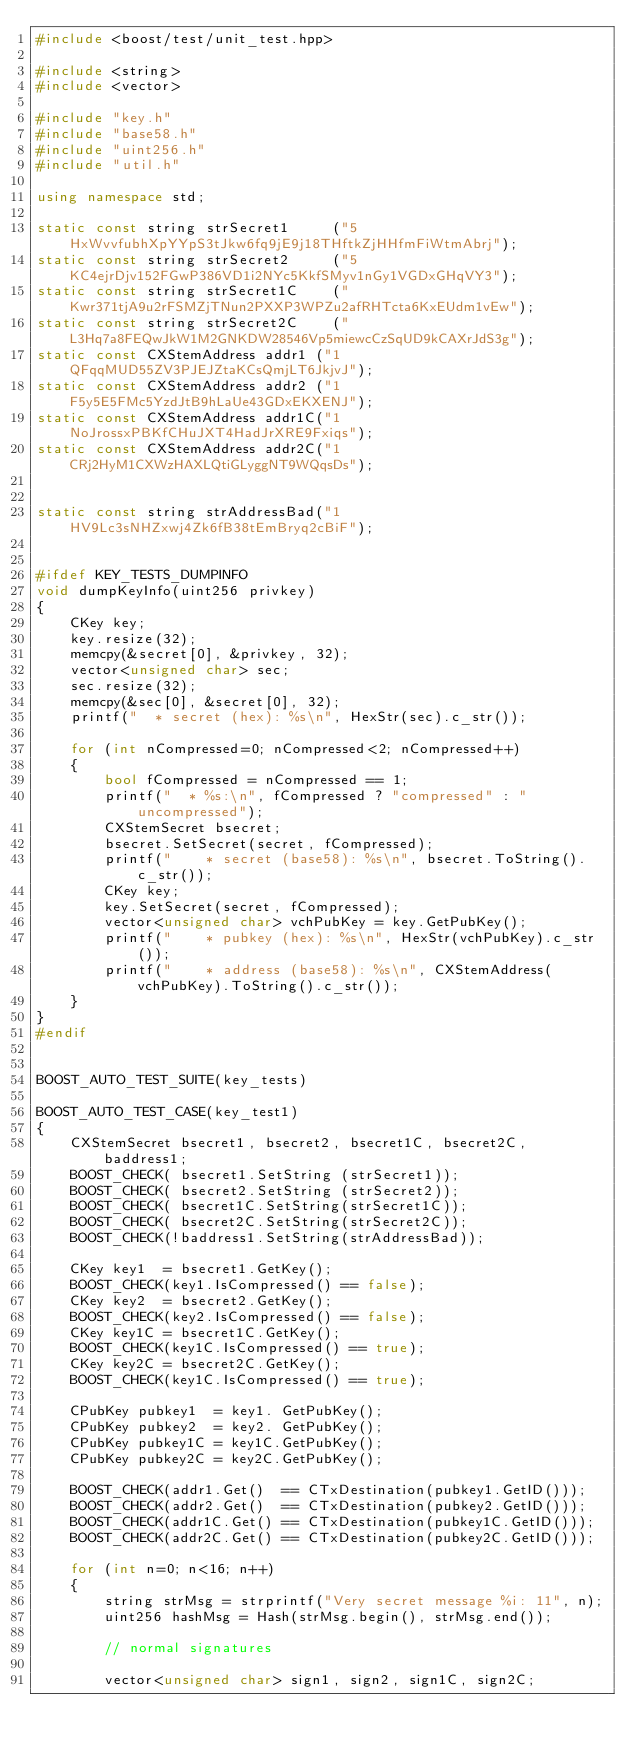Convert code to text. <code><loc_0><loc_0><loc_500><loc_500><_C++_>#include <boost/test/unit_test.hpp>

#include <string>
#include <vector>

#include "key.h"
#include "base58.h"
#include "uint256.h"
#include "util.h"

using namespace std;

static const string strSecret1     ("5HxWvvfubhXpYYpS3tJkw6fq9jE9j18THftkZjHHfmFiWtmAbrj");
static const string strSecret2     ("5KC4ejrDjv152FGwP386VD1i2NYc5KkfSMyv1nGy1VGDxGHqVY3");
static const string strSecret1C    ("Kwr371tjA9u2rFSMZjTNun2PXXP3WPZu2afRHTcta6KxEUdm1vEw");
static const string strSecret2C    ("L3Hq7a8FEQwJkW1M2GNKDW28546Vp5miewcCzSqUD9kCAXrJdS3g");
static const CXStemAddress addr1 ("1QFqqMUD55ZV3PJEJZtaKCsQmjLT6JkjvJ");
static const CXStemAddress addr2 ("1F5y5E5FMc5YzdJtB9hLaUe43GDxEKXENJ");
static const CXStemAddress addr1C("1NoJrossxPBKfCHuJXT4HadJrXRE9Fxiqs");
static const CXStemAddress addr2C("1CRj2HyM1CXWzHAXLQtiGLyggNT9WQqsDs");


static const string strAddressBad("1HV9Lc3sNHZxwj4Zk6fB38tEmBryq2cBiF");


#ifdef KEY_TESTS_DUMPINFO
void dumpKeyInfo(uint256 privkey)
{
    CKey key;
    key.resize(32);
    memcpy(&secret[0], &privkey, 32);
    vector<unsigned char> sec;
    sec.resize(32);
    memcpy(&sec[0], &secret[0], 32);
    printf("  * secret (hex): %s\n", HexStr(sec).c_str());

    for (int nCompressed=0; nCompressed<2; nCompressed++)
    {
        bool fCompressed = nCompressed == 1;
        printf("  * %s:\n", fCompressed ? "compressed" : "uncompressed");
        CXStemSecret bsecret;
        bsecret.SetSecret(secret, fCompressed);
        printf("    * secret (base58): %s\n", bsecret.ToString().c_str());
        CKey key;
        key.SetSecret(secret, fCompressed);
        vector<unsigned char> vchPubKey = key.GetPubKey();
        printf("    * pubkey (hex): %s\n", HexStr(vchPubKey).c_str());
        printf("    * address (base58): %s\n", CXStemAddress(vchPubKey).ToString().c_str());
    }
}
#endif


BOOST_AUTO_TEST_SUITE(key_tests)

BOOST_AUTO_TEST_CASE(key_test1)
{
    CXStemSecret bsecret1, bsecret2, bsecret1C, bsecret2C, baddress1;
    BOOST_CHECK( bsecret1.SetString (strSecret1));
    BOOST_CHECK( bsecret2.SetString (strSecret2));
    BOOST_CHECK( bsecret1C.SetString(strSecret1C));
    BOOST_CHECK( bsecret2C.SetString(strSecret2C));
    BOOST_CHECK(!baddress1.SetString(strAddressBad));

    CKey key1  = bsecret1.GetKey();
    BOOST_CHECK(key1.IsCompressed() == false);
    CKey key2  = bsecret2.GetKey();
    BOOST_CHECK(key2.IsCompressed() == false);
    CKey key1C = bsecret1C.GetKey();
    BOOST_CHECK(key1C.IsCompressed() == true);
    CKey key2C = bsecret2C.GetKey();
    BOOST_CHECK(key1C.IsCompressed() == true);

    CPubKey pubkey1  = key1. GetPubKey();
    CPubKey pubkey2  = key2. GetPubKey();
    CPubKey pubkey1C = key1C.GetPubKey();
    CPubKey pubkey2C = key2C.GetPubKey();

    BOOST_CHECK(addr1.Get()  == CTxDestination(pubkey1.GetID()));
    BOOST_CHECK(addr2.Get()  == CTxDestination(pubkey2.GetID()));
    BOOST_CHECK(addr1C.Get() == CTxDestination(pubkey1C.GetID()));
    BOOST_CHECK(addr2C.Get() == CTxDestination(pubkey2C.GetID()));

    for (int n=0; n<16; n++)
    {
        string strMsg = strprintf("Very secret message %i: 11", n);
        uint256 hashMsg = Hash(strMsg.begin(), strMsg.end());

        // normal signatures

        vector<unsigned char> sign1, sign2, sign1C, sign2C;
</code> 